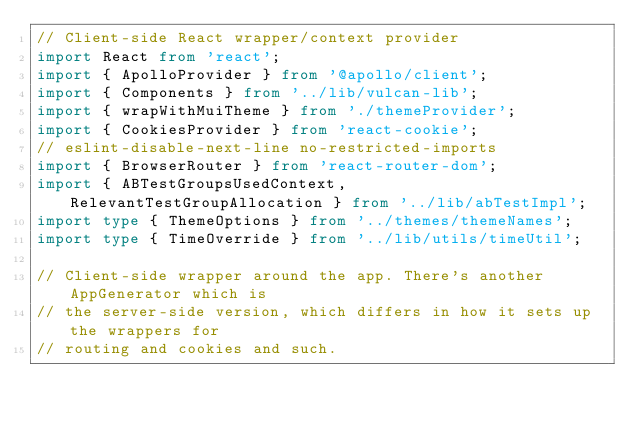Convert code to text. <code><loc_0><loc_0><loc_500><loc_500><_TypeScript_>// Client-side React wrapper/context provider
import React from 'react';
import { ApolloProvider } from '@apollo/client';
import { Components } from '../lib/vulcan-lib';
import { wrapWithMuiTheme } from './themeProvider';
import { CookiesProvider } from 'react-cookie';
// eslint-disable-next-line no-restricted-imports
import { BrowserRouter } from 'react-router-dom';
import { ABTestGroupsUsedContext, RelevantTestGroupAllocation } from '../lib/abTestImpl';
import type { ThemeOptions } from '../themes/themeNames';
import type { TimeOverride } from '../lib/utils/timeUtil';

// Client-side wrapper around the app. There's another AppGenerator which is
// the server-side version, which differs in how it sets up the wrappers for
// routing and cookies and such.</code> 